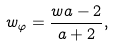<formula> <loc_0><loc_0><loc_500><loc_500>w _ { \varphi } = \frac { w a - 2 } { a + 2 } ,</formula> 